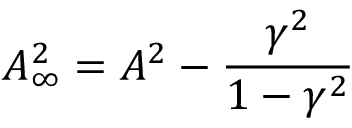Convert formula to latex. <formula><loc_0><loc_0><loc_500><loc_500>A _ { \infty } ^ { 2 } = A ^ { 2 } - \frac { \gamma ^ { 2 } } { 1 - \gamma ^ { 2 } }</formula> 